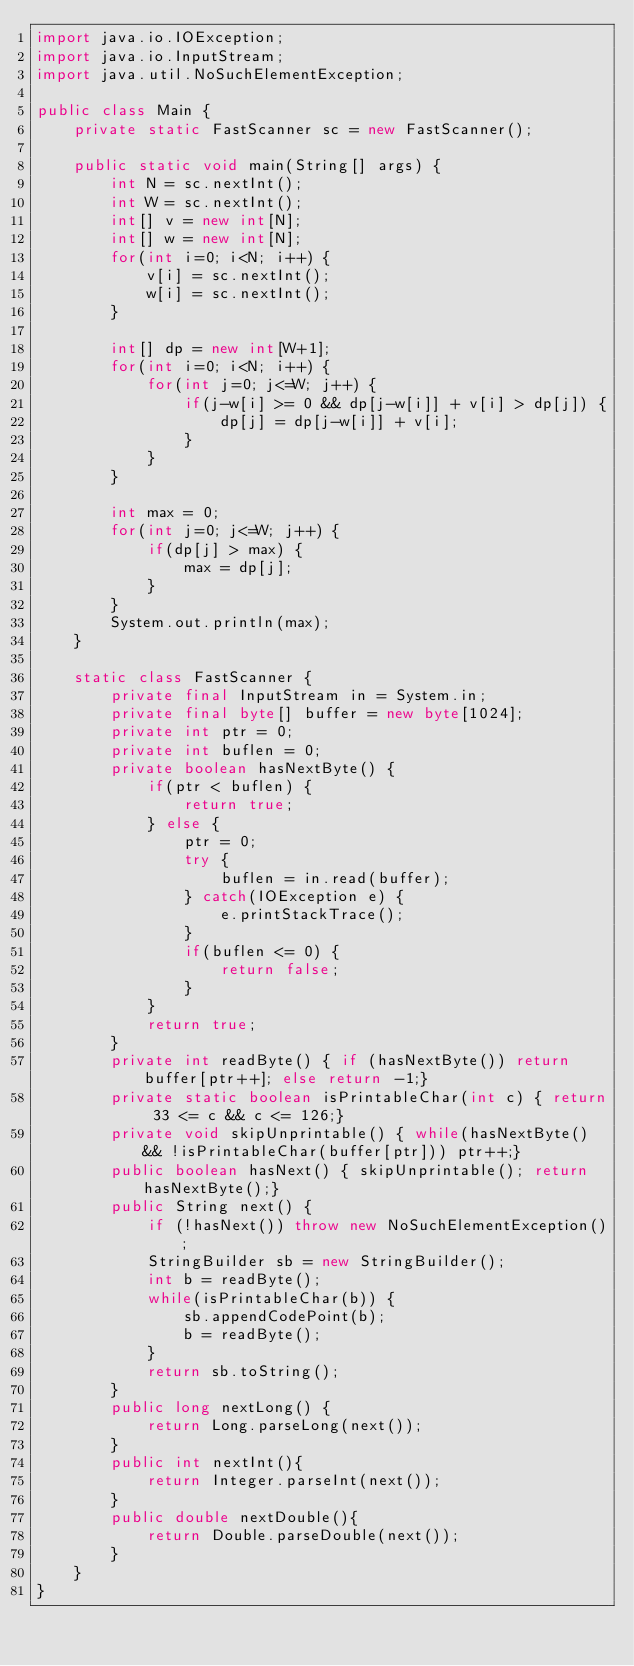Convert code to text. <code><loc_0><loc_0><loc_500><loc_500><_Java_>import java.io.IOException;
import java.io.InputStream;
import java.util.NoSuchElementException;
 
public class Main {
	private static FastScanner sc = new FastScanner();
	
	public static void main(String[] args) {
		int N = sc.nextInt();
		int W = sc.nextInt();
		int[] v = new int[N];
		int[] w = new int[N];
		for(int i=0; i<N; i++) {
			v[i] = sc.nextInt();
			w[i] = sc.nextInt();
		}
		
		int[] dp = new int[W+1];
		for(int i=0; i<N; i++) {
			for(int j=0; j<=W; j++) {
				if(j-w[i] >= 0 && dp[j-w[i]] + v[i] > dp[j]) {
					dp[j] = dp[j-w[i]] + v[i];
				}
			}
		}
		
		int max = 0;
		for(int j=0; j<=W; j++) {
			if(dp[j] > max) {
				max = dp[j];
			}
		}
		System.out.println(max);
	}
	
	static class FastScanner {
        private final InputStream in = System.in;
        private final byte[] buffer = new byte[1024];
        private int ptr = 0;
        private int buflen = 0;
        private boolean hasNextByte() {
            if(ptr < buflen) {
                return true;
            } else {
                ptr = 0;
                try {
                    buflen = in.read(buffer);
                } catch(IOException e) {
                    e.printStackTrace();
                }
                if(buflen <= 0) {
                    return false;
                }
            }
            return true;
        }
        private int readByte() { if (hasNextByte()) return buffer[ptr++]; else return -1;}
        private static boolean isPrintableChar(int c) { return 33 <= c && c <= 126;}
        private void skipUnprintable() { while(hasNextByte() && !isPrintableChar(buffer[ptr])) ptr++;}
        public boolean hasNext() { skipUnprintable(); return hasNextByte();}
        public String next() {
            if (!hasNext()) throw new NoSuchElementException();
            StringBuilder sb = new StringBuilder();
            int b = readByte();
            while(isPrintableChar(b)) {
                sb.appendCodePoint(b);
                b = readByte();
            }
            return sb.toString();
        }
        public long nextLong() {
            return Long.parseLong(next());
        }
        public int nextInt(){
            return Integer.parseInt(next());
        }
        public double nextDouble(){
            return Double.parseDouble(next());
        }
    }
}</code> 